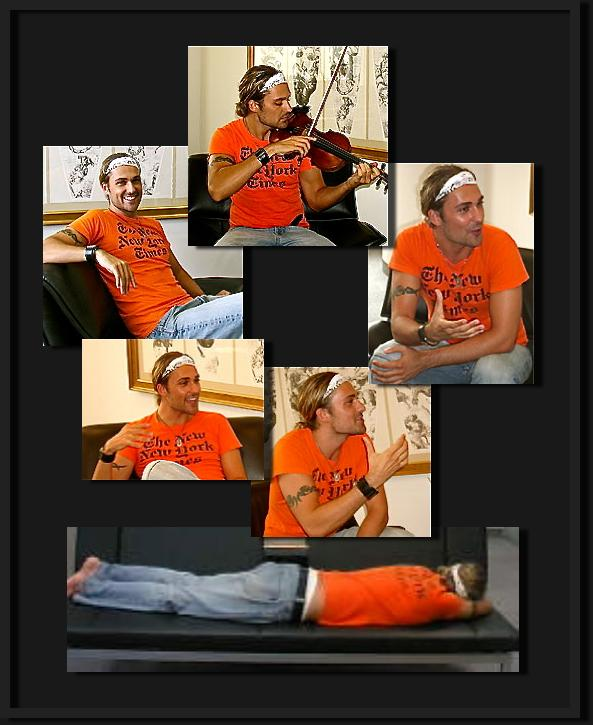What might the text on the man's t-shirt signify about the event or organization he is associated with? The text on the man's t-shirt likely represents a specific organization or event theme, suggesting involvement in a group identified by casual and creative engagements. This can imply the man's active participation in a community-focused or hobby-related event that values inclusivity and interaction among its members. 